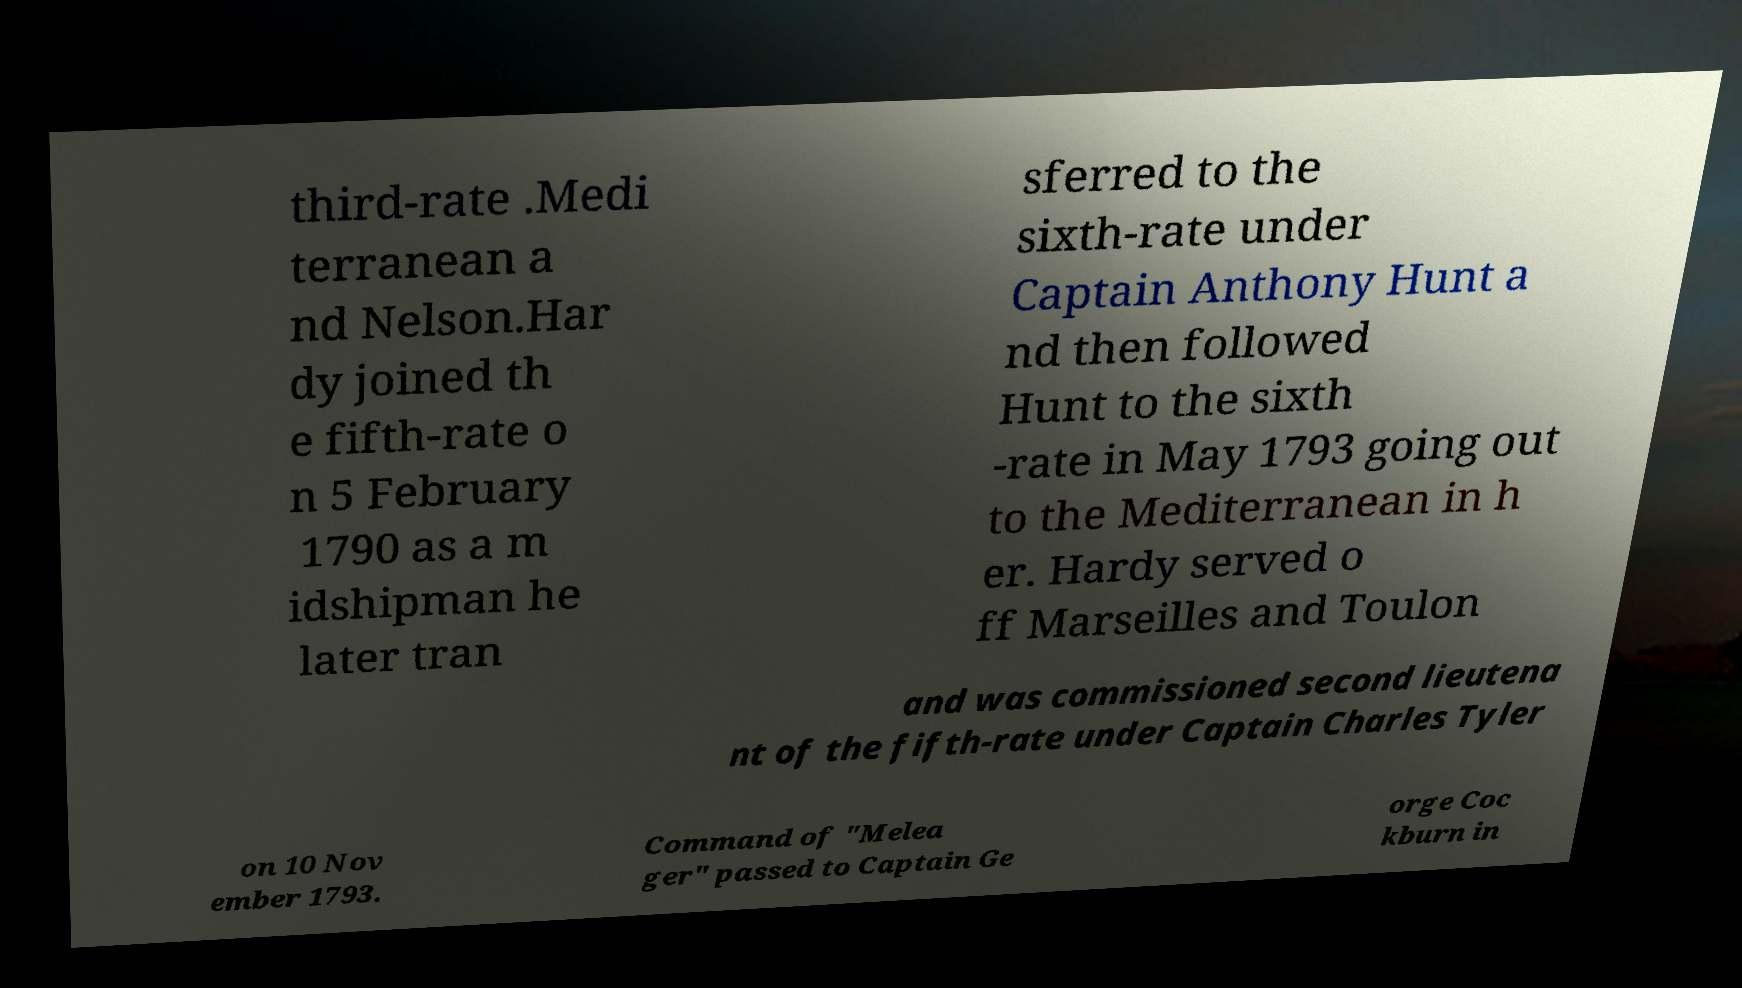Can you accurately transcribe the text from the provided image for me? third-rate .Medi terranean a nd Nelson.Har dy joined th e fifth-rate o n 5 February 1790 as a m idshipman he later tran sferred to the sixth-rate under Captain Anthony Hunt a nd then followed Hunt to the sixth -rate in May 1793 going out to the Mediterranean in h er. Hardy served o ff Marseilles and Toulon and was commissioned second lieutena nt of the fifth-rate under Captain Charles Tyler on 10 Nov ember 1793. Command of "Melea ger" passed to Captain Ge orge Coc kburn in 